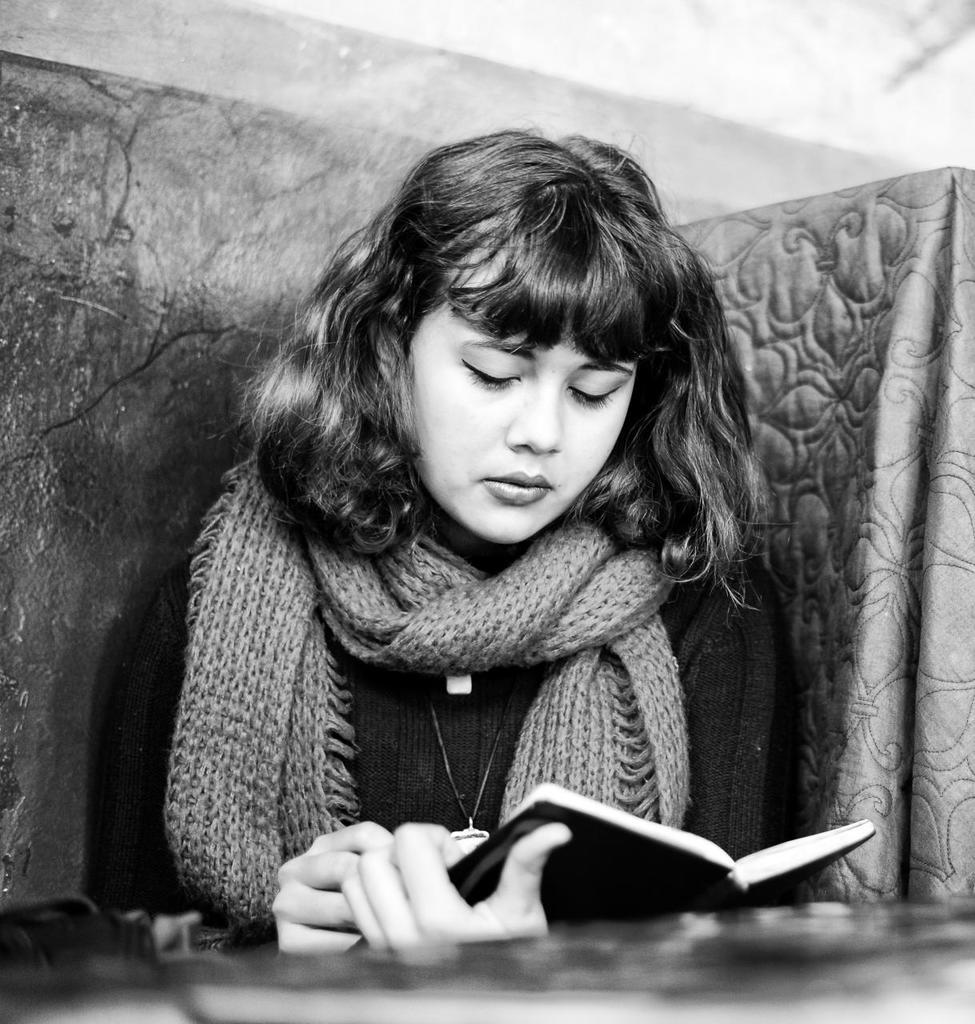What is the main subject of the image? There is a person in the image. What is the person wearing? The person is wearing a dress. What is the person holding in the image? The person is holding a book. Can you describe the appearance of the image? The image is black and white. What is the area in front of the person like? The area in front of the person is blurred. What brand of toothpaste is the person using in the image? There is no toothpaste present in the image. Is the person riding a bike in the image? There is no bike present in the image. 